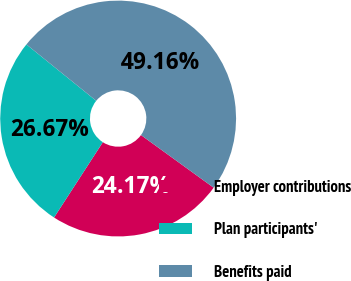Convert chart. <chart><loc_0><loc_0><loc_500><loc_500><pie_chart><fcel>Employer contributions<fcel>Plan participants'<fcel>Benefits paid<nl><fcel>24.17%<fcel>26.67%<fcel>49.16%<nl></chart> 